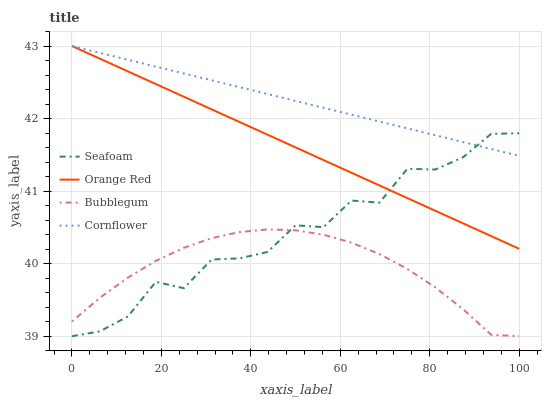Does Bubblegum have the minimum area under the curve?
Answer yes or no. Yes. Does Cornflower have the maximum area under the curve?
Answer yes or no. Yes. Does Seafoam have the minimum area under the curve?
Answer yes or no. No. Does Seafoam have the maximum area under the curve?
Answer yes or no. No. Is Orange Red the smoothest?
Answer yes or no. Yes. Is Seafoam the roughest?
Answer yes or no. Yes. Is Bubblegum the smoothest?
Answer yes or no. No. Is Bubblegum the roughest?
Answer yes or no. No. Does Seafoam have the lowest value?
Answer yes or no. Yes. Does Orange Red have the lowest value?
Answer yes or no. No. Does Orange Red have the highest value?
Answer yes or no. Yes. Does Seafoam have the highest value?
Answer yes or no. No. Is Bubblegum less than Cornflower?
Answer yes or no. Yes. Is Orange Red greater than Bubblegum?
Answer yes or no. Yes. Does Orange Red intersect Seafoam?
Answer yes or no. Yes. Is Orange Red less than Seafoam?
Answer yes or no. No. Is Orange Red greater than Seafoam?
Answer yes or no. No. Does Bubblegum intersect Cornflower?
Answer yes or no. No. 